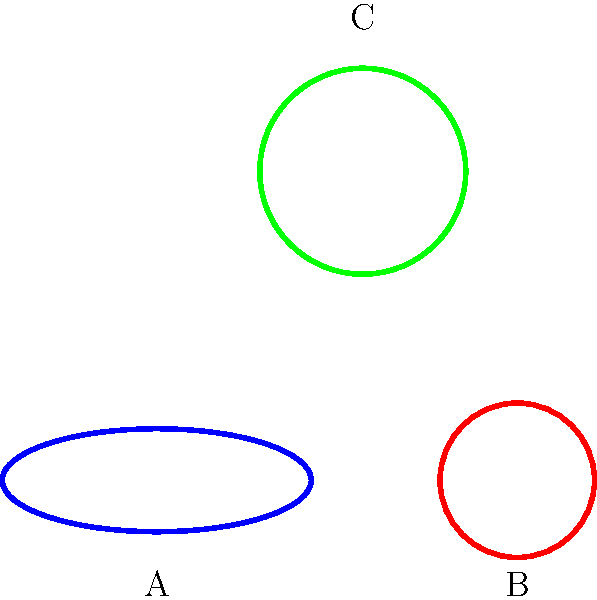Consider the three 2D manifolds shown in the figure: A (blue), B (red), and C (green). These represent a torus, a sphere, and a Klein bottle, respectively. Based on their topological properties, which of these manifolds has an Euler characteristic ($\chi$) of 0 and a genus (g) of 1? To answer this question, we need to understand the relationship between Euler characteristic ($\chi$), genus (g), and the topological properties of 2D manifolds. Let's analyze each shape:

1. For a closed orientable surface, the Euler characteristic is related to the genus by the formula:
   $\chi = 2 - 2g$

2. Sphere (B):
   - Euler characteristic: $\chi = 2$
   - Genus: $g = 0$
   - It satisfies the formula: $2 = 2 - 2(0)$

3. Torus (A):
   - Euler characteristic: $\chi = 0$
   - Genus: $g = 1$
   - It satisfies the formula: $0 = 2 - 2(1)$

4. Klein bottle (C):
   - Euler characteristic: $\chi = 0$
   - Genus: $g = 2$ (for non-orientable surfaces, the formula is $\chi = 2 - g$)
   - It satisfies the formula for non-orientable surfaces: $0 = 2 - 2$

The question asks for a manifold with $\chi = 0$ and $g = 1$. Only the torus (A) satisfies both these conditions.
Answer: A (Torus) 